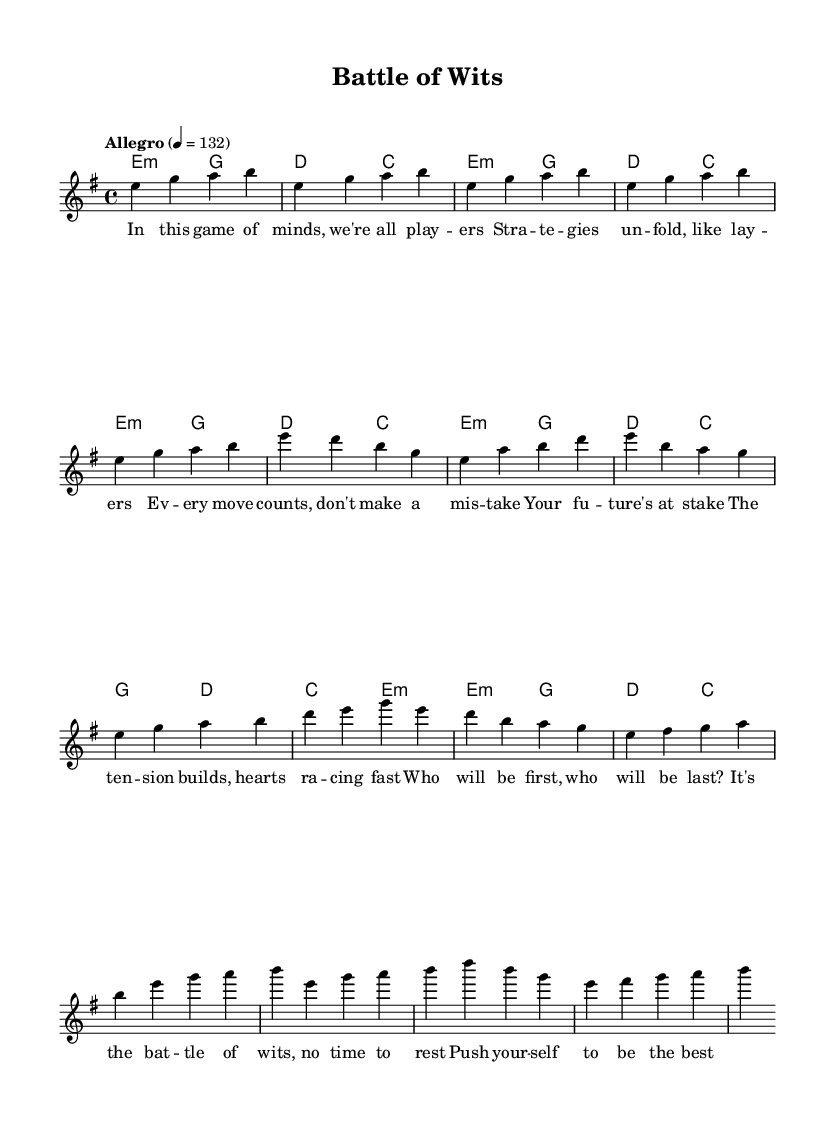What is the key signature of this music? The key signature is indicated at the beginning of the score, and it shows one sharp (F#), which corresponds to E minor.
Answer: E minor What is the time signature of the piece? The time signature is found at the start of the staff, showing four beats per measure, which is represented as 4/4.
Answer: 4/4 What is the tempo marking of the song? The tempo marking is found at the beginning of the score, indicating "Allegro" with a metronome marking of 132 beats per minute.
Answer: Allegro, 132 How many sections does this song have? The song is structured in three main sections: Verse, Pre-Chorus, and Chorus, which are labeled in the lyrics.
Answer: Three What chord is played at the start of the intro? The first chord is indicated in the harmonies section and shows E minor, which starts the piece.
Answer: E minor Which line of the lyrics corresponds to the Chorus? The Chorus is clearly labeled in the lyrics section and consists of the lines starting with "It's the battle of wits."
Answer: It's the battle of wits, no time to rest How does the melody in the Pre-Chorus differ from the Verse? The melody in the Pre-Chorus involves a higher range of notes and a different rhythmic structure compared to the Verse, building tension in preparation for the Chorus.
Answer: Higher range 